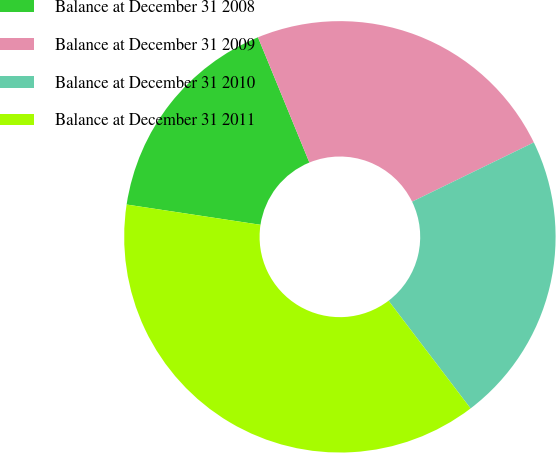<chart> <loc_0><loc_0><loc_500><loc_500><pie_chart><fcel>Balance at December 31 2008<fcel>Balance at December 31 2009<fcel>Balance at December 31 2010<fcel>Balance at December 31 2011<nl><fcel>16.41%<fcel>23.99%<fcel>21.85%<fcel>37.75%<nl></chart> 